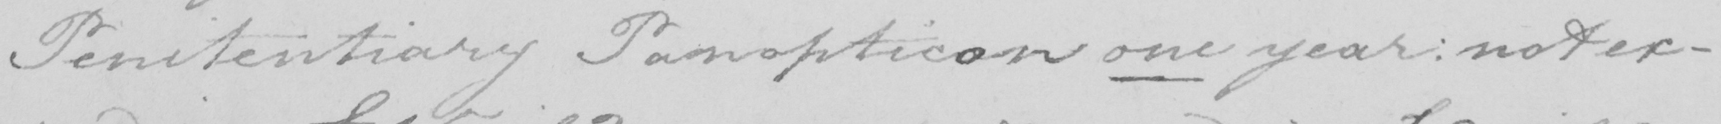What is written in this line of handwriting? Penitentiary Panopticon one year  :  not ex- 